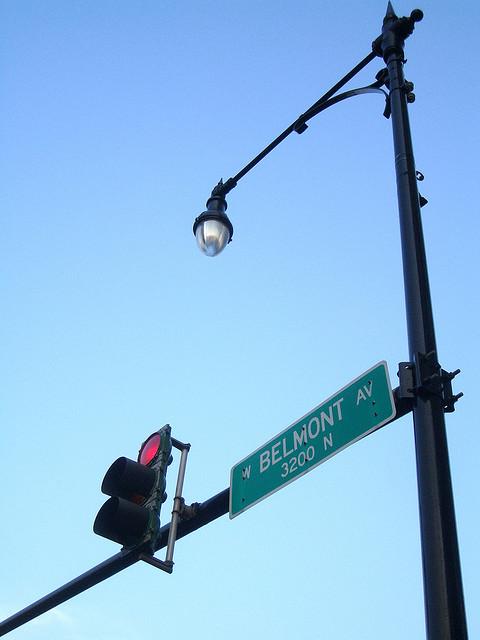Is the light on?
Be succinct. Yes. What is the street name?
Quick response, please. Belmont. Is the traffic light red?
Keep it brief. Yes. Is this a light pole?
Keep it brief. Yes. 